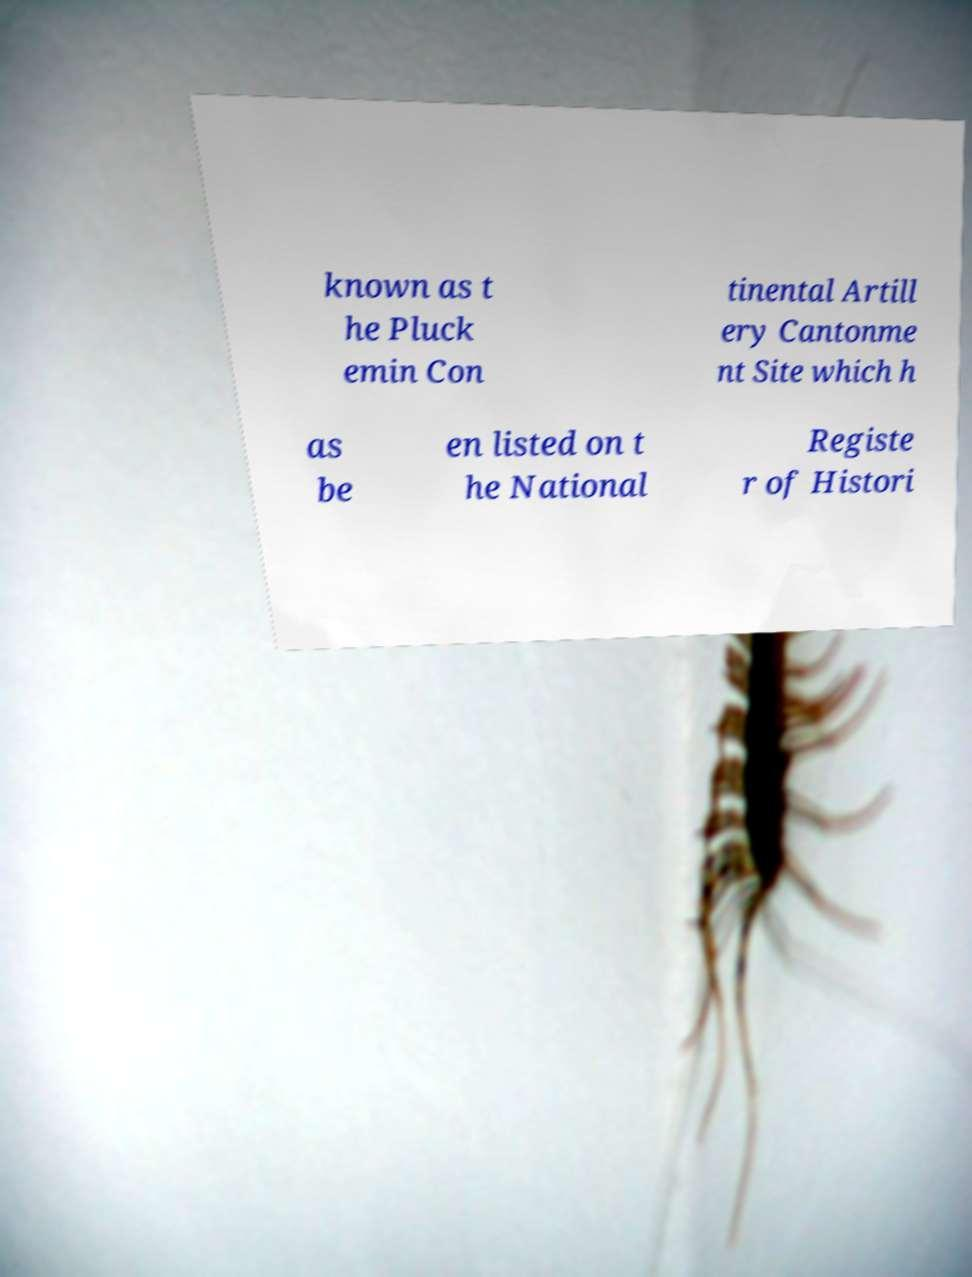Can you accurately transcribe the text from the provided image for me? known as t he Pluck emin Con tinental Artill ery Cantonme nt Site which h as be en listed on t he National Registe r of Histori 